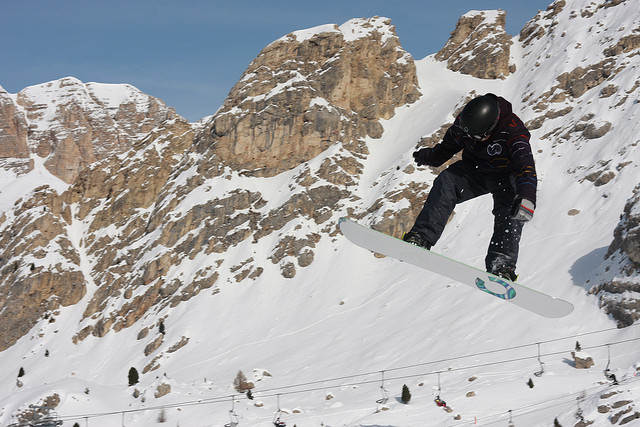What is the main activity taking place in the image? The main activity depicted in the image is snowboarding. A person is airborne, performing an impressive snowboard maneuver on a snowy mountain slope. 